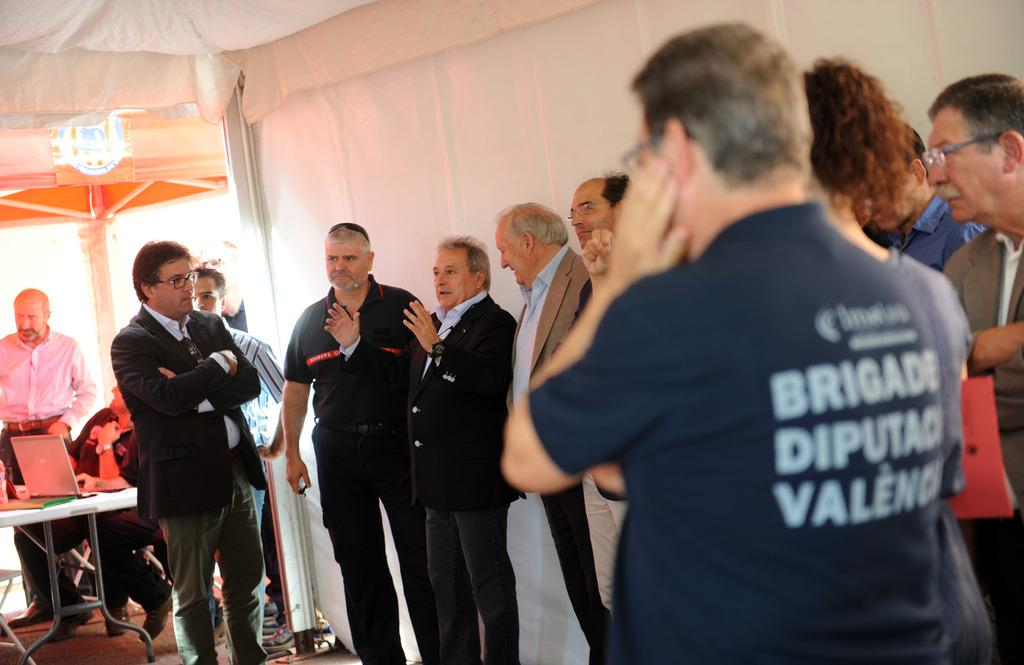How many people are in the image? There is a group of persons in the image. What are the persons in the image doing? The persons are standing and discussing something. What can be seen in the background of the image? There is a white color curtain in the background of the image. What type of carriage can be seen in the image? There is no carriage present in the image; it features a group of persons standing and discussing something. How many circles are visible in the image? There is no circle present in the image. 